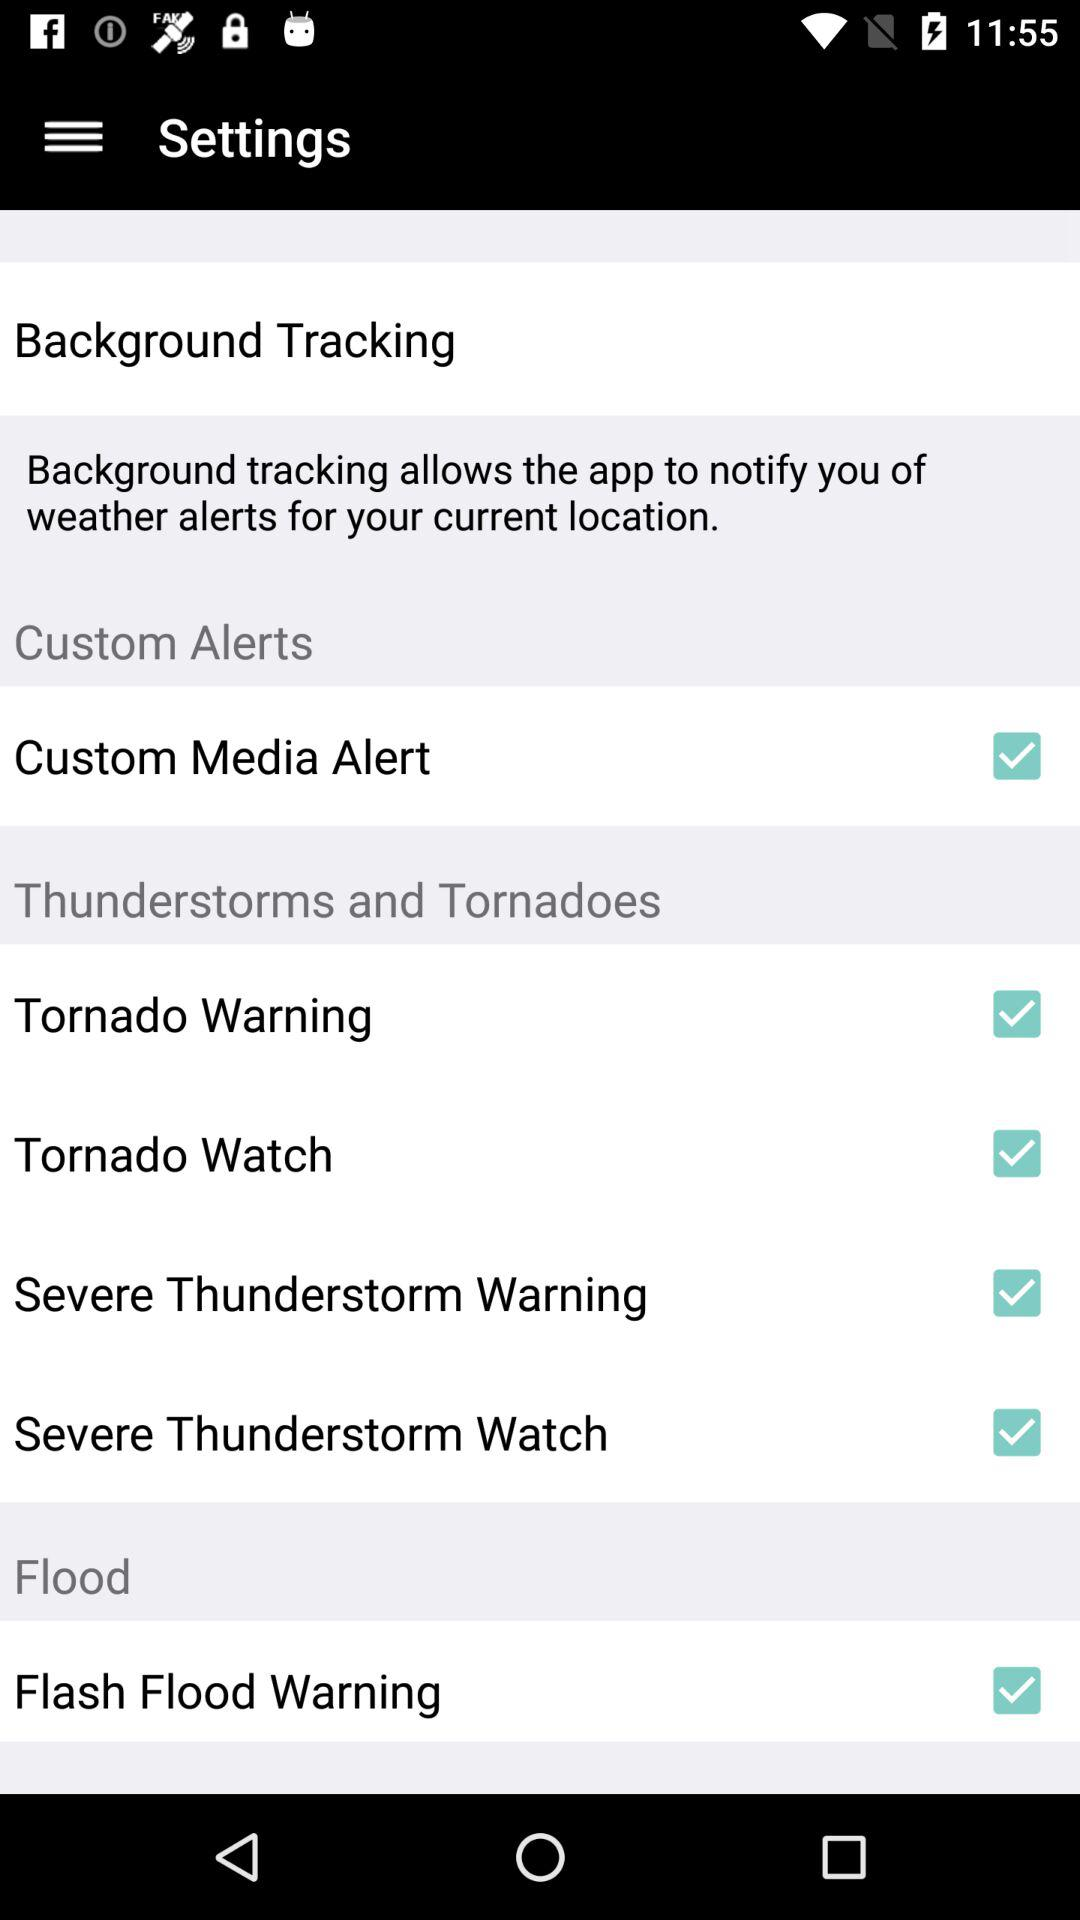What is the status of the "Custom Media Alert"? The status is on. 